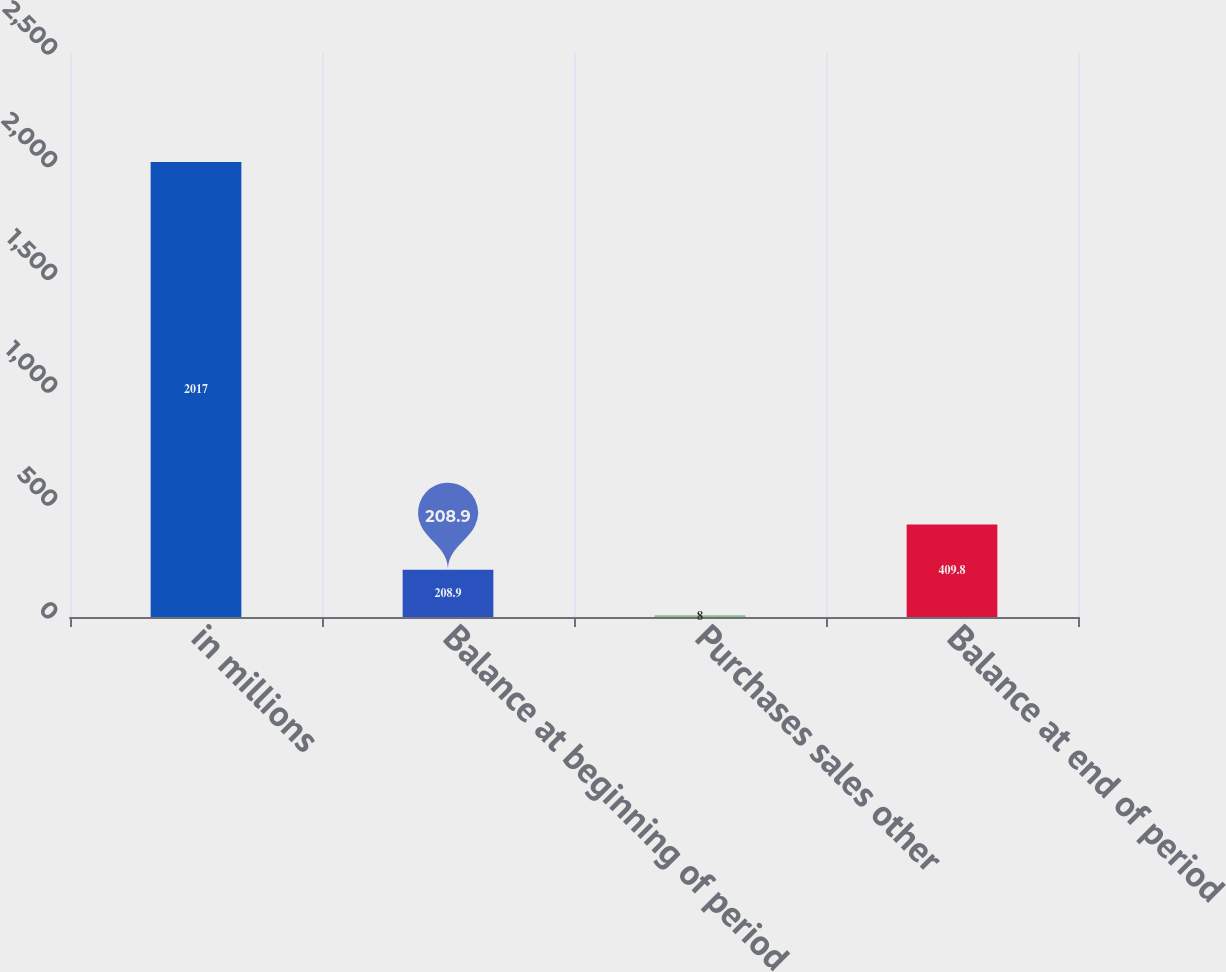Convert chart. <chart><loc_0><loc_0><loc_500><loc_500><bar_chart><fcel>in millions<fcel>Balance at beginning of period<fcel>Purchases sales other<fcel>Balance at end of period<nl><fcel>2017<fcel>208.9<fcel>8<fcel>409.8<nl></chart> 